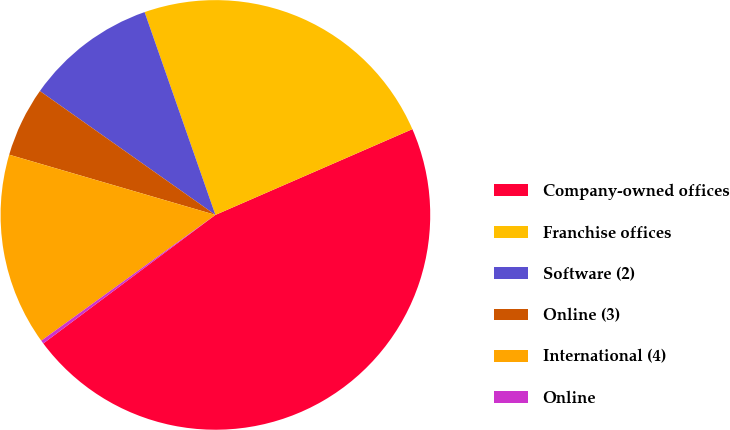<chart> <loc_0><loc_0><loc_500><loc_500><pie_chart><fcel>Company-owned offices<fcel>Franchise offices<fcel>Software (2)<fcel>Online (3)<fcel>International (4)<fcel>Online<nl><fcel>46.33%<fcel>23.81%<fcel>9.87%<fcel>5.26%<fcel>14.48%<fcel>0.25%<nl></chart> 